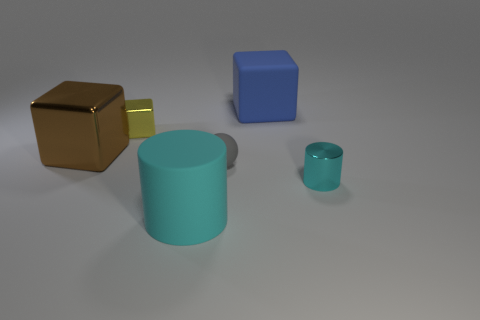If these objects represented characters in a story, what roles might they play based on their appearance and position? Intriguing thought! The large brown cube could be the steadfast guardian of this realm, a symbol of strength and resilience. The small yellow cube might be the guardian's trusted companion or a treasure in this geometric land, a beacon of hope and prosperity. The cyan cylinders could be siblings in our tale, with the larger one serving as a sage, a pillar of wisdom, while the little one could be the eager apprentice or the sage's youthful charge, full of potential and curiosity. The blue cube, distant and aloof, may represent a traveler or a mystic, one who holds ancient knowledge and observes the dynamics of the others from a thoughtful remove. 